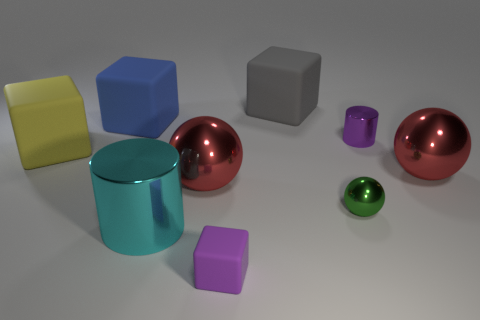How many objects in total are visible in the image? In total, there are eight objects visible in the image: two large rubber cubes, three shiny spheres, one cylinder, and two small cubes. 